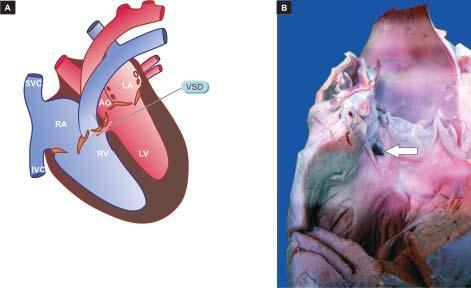do the myocardial muscle fibres show a communication in the inter-ventricular septum superiorly white arrow?
Answer the question using a single word or phrase. No 